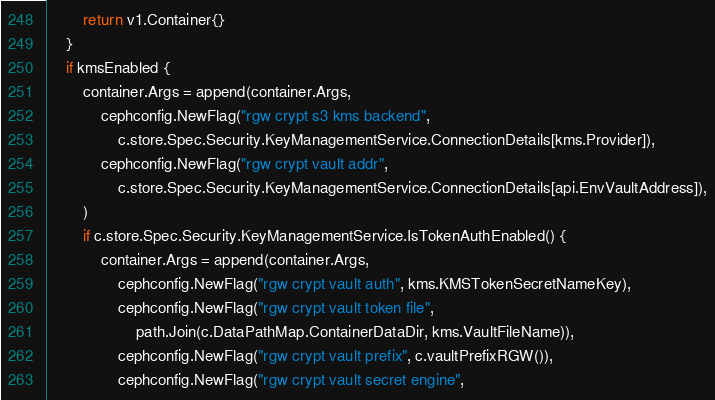Convert code to text. <code><loc_0><loc_0><loc_500><loc_500><_Go_>		return v1.Container{}
	}
	if kmsEnabled {
		container.Args = append(container.Args,
			cephconfig.NewFlag("rgw crypt s3 kms backend",
				c.store.Spec.Security.KeyManagementService.ConnectionDetails[kms.Provider]),
			cephconfig.NewFlag("rgw crypt vault addr",
				c.store.Spec.Security.KeyManagementService.ConnectionDetails[api.EnvVaultAddress]),
		)
		if c.store.Spec.Security.KeyManagementService.IsTokenAuthEnabled() {
			container.Args = append(container.Args,
				cephconfig.NewFlag("rgw crypt vault auth", kms.KMSTokenSecretNameKey),
				cephconfig.NewFlag("rgw crypt vault token file",
					path.Join(c.DataPathMap.ContainerDataDir, kms.VaultFileName)),
				cephconfig.NewFlag("rgw crypt vault prefix", c.vaultPrefixRGW()),
				cephconfig.NewFlag("rgw crypt vault secret engine",</code> 